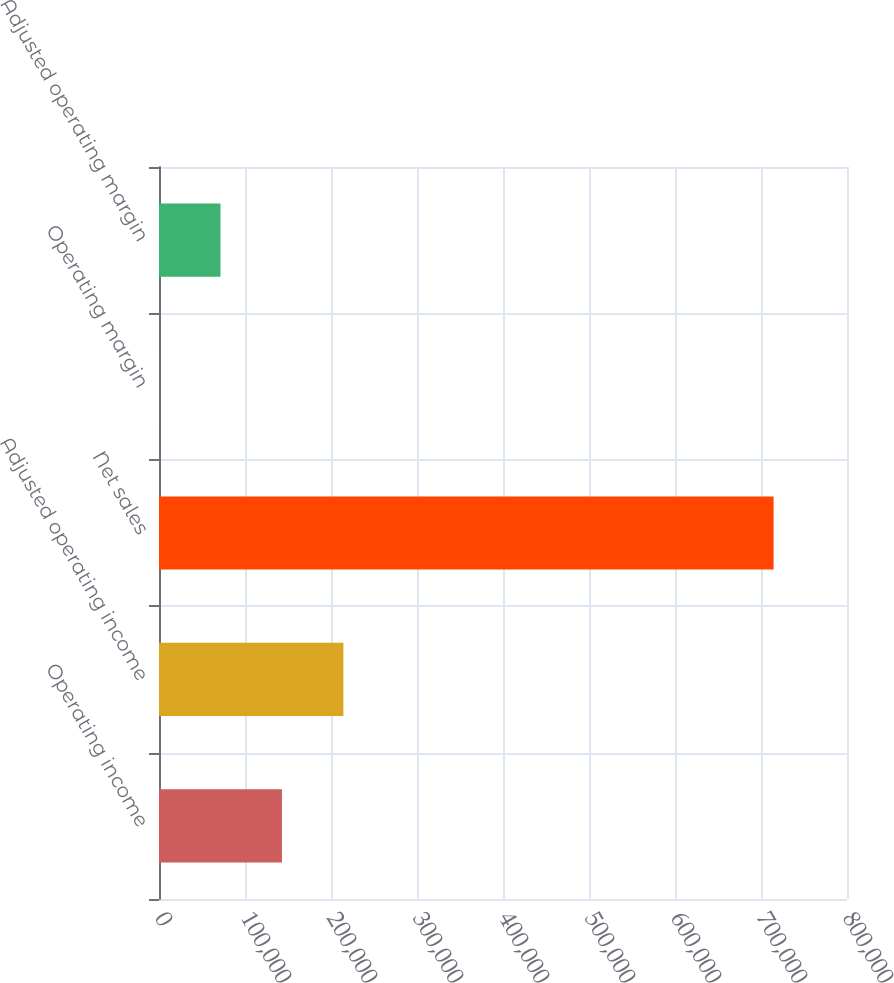Convert chart. <chart><loc_0><loc_0><loc_500><loc_500><bar_chart><fcel>Operating income<fcel>Adjusted operating income<fcel>Net sales<fcel>Operating margin<fcel>Adjusted operating margin<nl><fcel>142945<fcel>214408<fcel>714650<fcel>19.1<fcel>71482.2<nl></chart> 